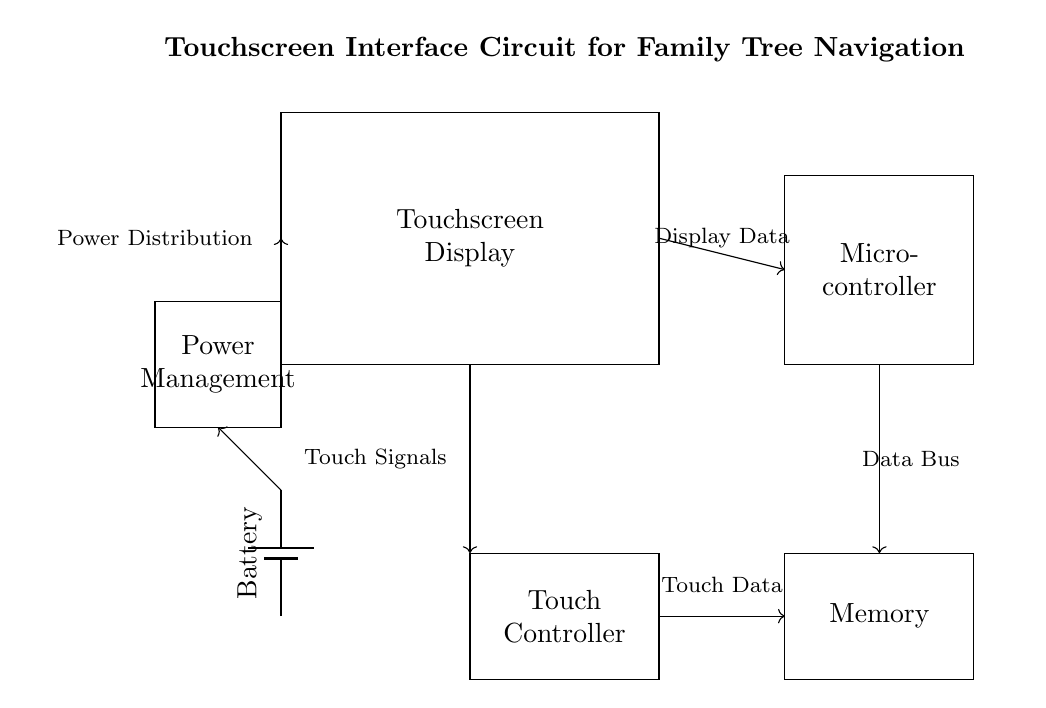What is the main component that functions as the interface for user interaction? The main component that enables user interaction is the touchscreen display, which allows users to input touch data for navigation.
Answer: touchscreen display What connects the touchscreen display to the microcontroller? The connection between the touchscreen display and the microcontroller is through display data lines that convey input signals to the microcontroller for processing.
Answer: display data What type of power supply is used in this circuit? The circuit uses a battery as the power supply, providing the necessary power to the entire system, demonstrated by the battery symbol.
Answer: battery Which component stores data in this circuit? The memory component is responsible for storing data, including familial information and user inputs, allowing the microcontroller to retrieve necessary data during navigation.
Answer: memory How does touch data from the touchscreen reach the microcontroller? Touch data from the touchscreen is sent directly to the microcontroller via the touch controller, which translates the touch signals into digital format that the microcontroller can process.
Answer: touch controller What role does the power management unit play in this circuit? The power management unit distributes power efficiently to the touchscreen, microcontroller, memory, and other components, ensuring that each part of the circuit receives the correct voltage and current for operation.
Answer: power management How is the touchscreen display powered? The touchscreen display is powered through the power management unit, which receives power from the battery and regulates it for the display's requirements.
Answer: power management 